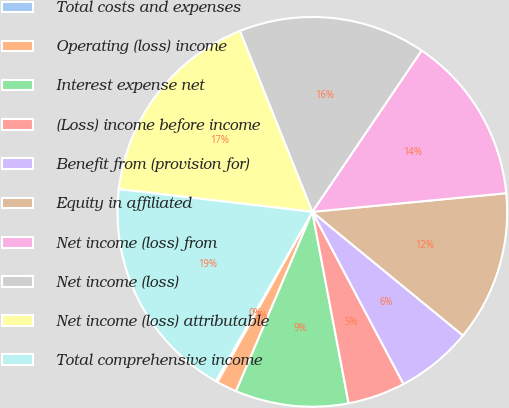Convert chart to OTSL. <chart><loc_0><loc_0><loc_500><loc_500><pie_chart><fcel>Total costs and expenses<fcel>Operating (loss) income<fcel>Interest expense net<fcel>(Loss) income before income<fcel>Benefit from (provision for)<fcel>Equity in affiliated<fcel>Net income (loss) from<fcel>Net income (loss)<fcel>Net income (loss) attributable<fcel>Total comprehensive income<nl><fcel>0.16%<fcel>1.69%<fcel>9.38%<fcel>4.77%<fcel>6.31%<fcel>12.46%<fcel>14.0%<fcel>15.54%<fcel>17.08%<fcel>18.61%<nl></chart> 